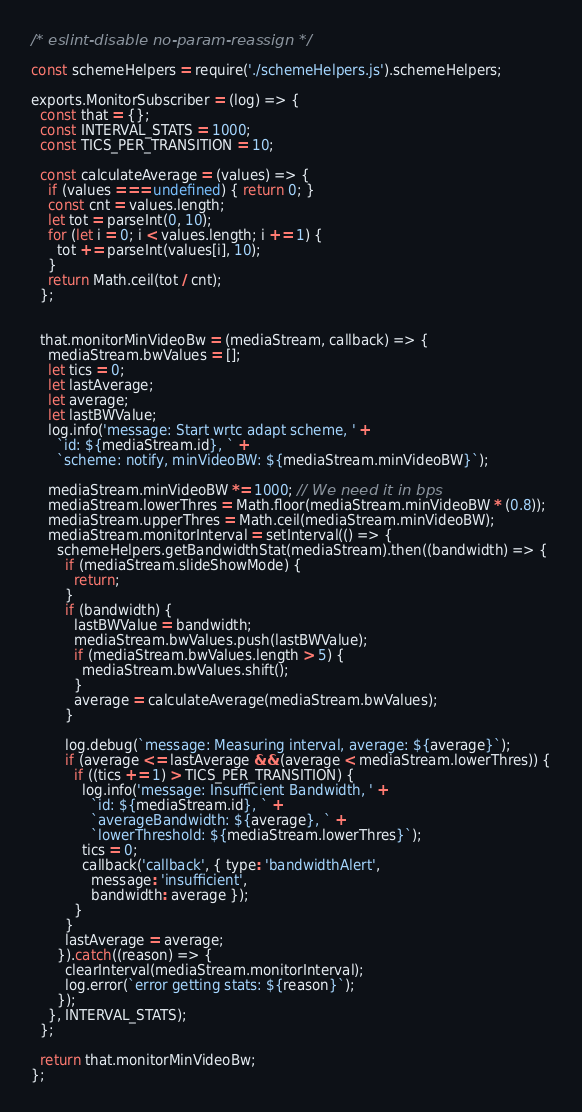Convert code to text. <code><loc_0><loc_0><loc_500><loc_500><_JavaScript_>/* eslint-disable no-param-reassign */

const schemeHelpers = require('./schemeHelpers.js').schemeHelpers;

exports.MonitorSubscriber = (log) => {
  const that = {};
  const INTERVAL_STATS = 1000;
  const TICS_PER_TRANSITION = 10;

  const calculateAverage = (values) => {
    if (values === undefined) { return 0; }
    const cnt = values.length;
    let tot = parseInt(0, 10);
    for (let i = 0; i < values.length; i += 1) {
      tot += parseInt(values[i], 10);
    }
    return Math.ceil(tot / cnt);
  };


  that.monitorMinVideoBw = (mediaStream, callback) => {
    mediaStream.bwValues = [];
    let tics = 0;
    let lastAverage;
    let average;
    let lastBWValue;
    log.info('message: Start wrtc adapt scheme, ' +
      `id: ${mediaStream.id}, ` +
      `scheme: notify, minVideoBW: ${mediaStream.minVideoBW}`);

    mediaStream.minVideoBW *= 1000; // We need it in bps
    mediaStream.lowerThres = Math.floor(mediaStream.minVideoBW * (0.8));
    mediaStream.upperThres = Math.ceil(mediaStream.minVideoBW);
    mediaStream.monitorInterval = setInterval(() => {
      schemeHelpers.getBandwidthStat(mediaStream).then((bandwidth) => {
        if (mediaStream.slideShowMode) {
          return;
        }
        if (bandwidth) {
          lastBWValue = bandwidth;
          mediaStream.bwValues.push(lastBWValue);
          if (mediaStream.bwValues.length > 5) {
            mediaStream.bwValues.shift();
          }
          average = calculateAverage(mediaStream.bwValues);
        }

        log.debug(`message: Measuring interval, average: ${average}`);
        if (average <= lastAverage && (average < mediaStream.lowerThres)) {
          if ((tics += 1) > TICS_PER_TRANSITION) {
            log.info('message: Insufficient Bandwidth, ' +
              `id: ${mediaStream.id}, ` +
              `averageBandwidth: ${average}, ` +
              `lowerThreshold: ${mediaStream.lowerThres}`);
            tics = 0;
            callback('callback', { type: 'bandwidthAlert',
              message: 'insufficient',
              bandwidth: average });
          }
        }
        lastAverage = average;
      }).catch((reason) => {
        clearInterval(mediaStream.monitorInterval);
        log.error(`error getting stats: ${reason}`);
      });
    }, INTERVAL_STATS);
  };

  return that.monitorMinVideoBw;
};
</code> 